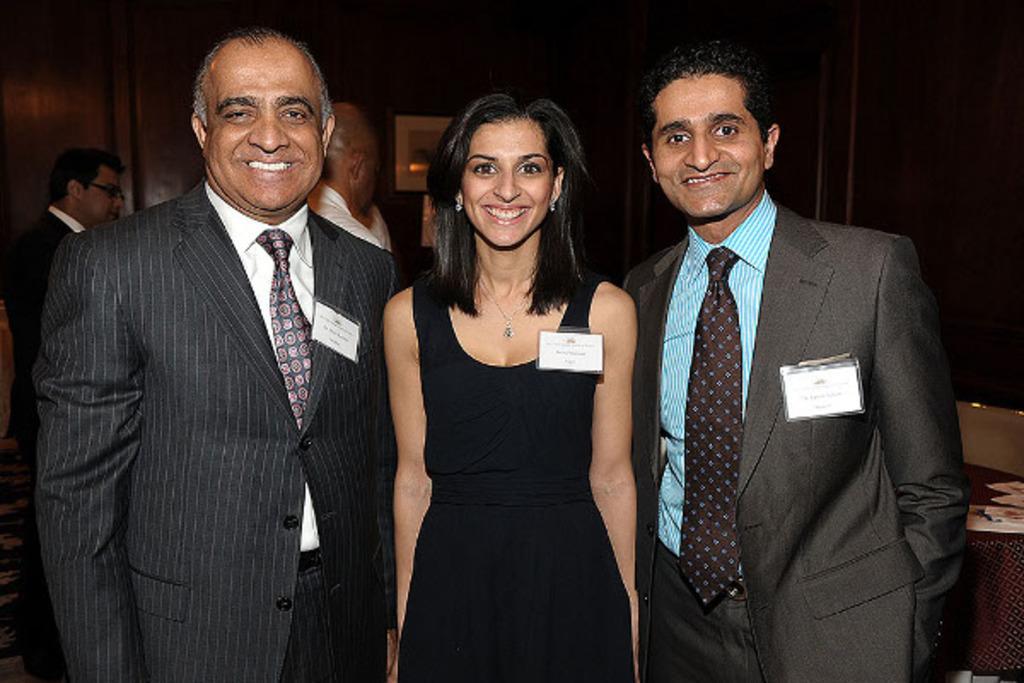Can you describe this image briefly? In this picture there are group of people standing and smiling. At the back there are group of people and there are frames on the wall. On the right side of the image there are papers on the table and there is a chair. 